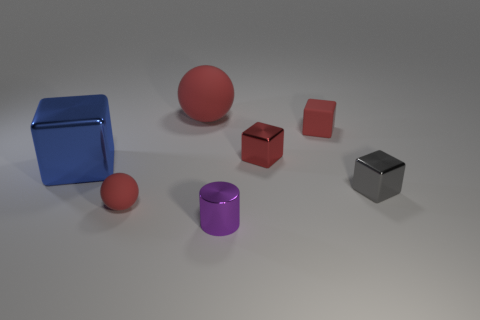Is there anything else that is made of the same material as the purple cylinder?
Ensure brevity in your answer.  Yes. Are there the same number of tiny matte cubes left of the tiny red matte cube and cubes in front of the gray metallic object?
Give a very brief answer. Yes. Is the large blue cube made of the same material as the big red sphere?
Provide a short and direct response. No. What number of red things are matte balls or big spheres?
Your response must be concise. 2. How many small red rubber things have the same shape as the big blue metallic object?
Your answer should be very brief. 1. What material is the tiny purple cylinder?
Your answer should be very brief. Metal. Are there an equal number of small purple objects that are to the left of the tiny red ball and large cubes?
Offer a very short reply. No. There is a gray shiny object that is the same size as the matte block; what shape is it?
Keep it short and to the point. Cube. There is a small red rubber object behind the small red metal thing; are there any red objects that are on the right side of it?
Your answer should be compact. No. What number of big things are green metal blocks or purple objects?
Provide a succinct answer. 0. 